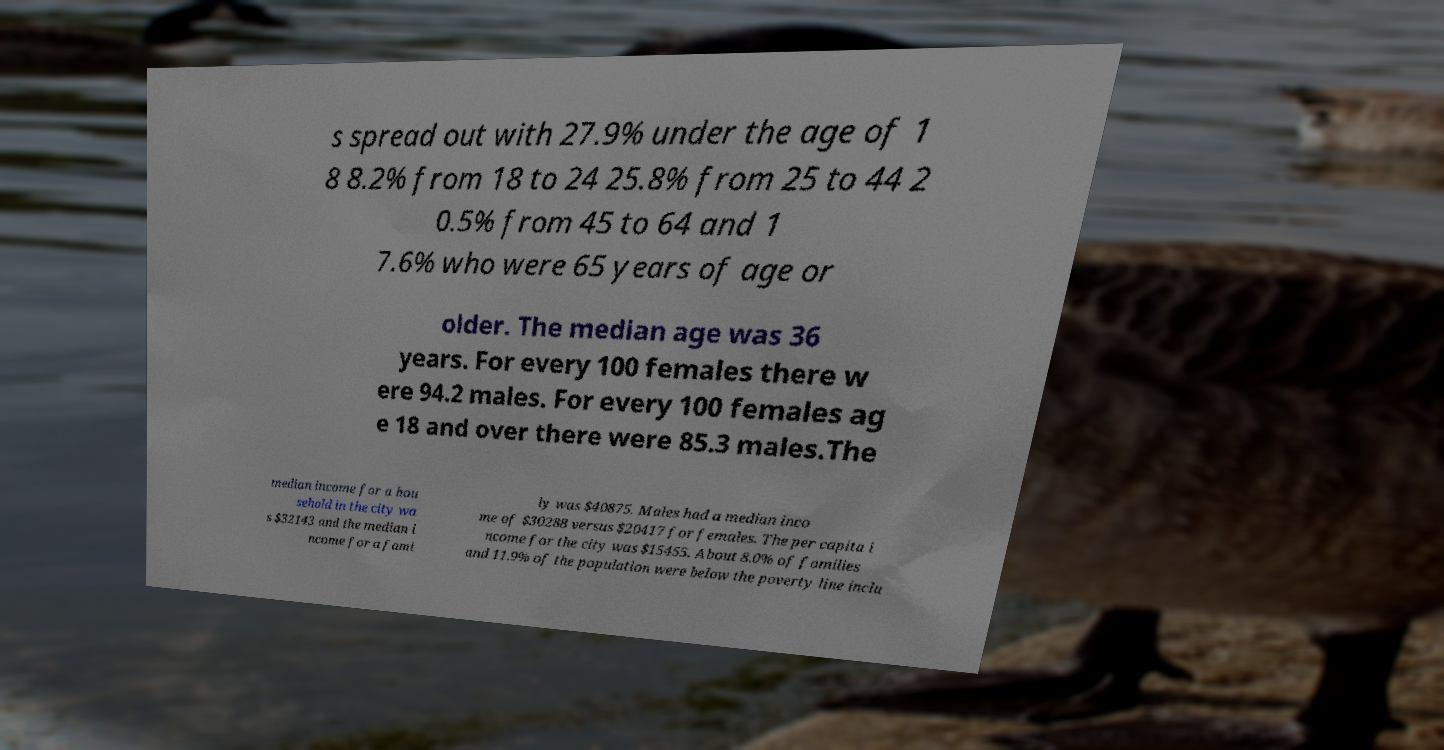Could you assist in decoding the text presented in this image and type it out clearly? s spread out with 27.9% under the age of 1 8 8.2% from 18 to 24 25.8% from 25 to 44 2 0.5% from 45 to 64 and 1 7.6% who were 65 years of age or older. The median age was 36 years. For every 100 females there w ere 94.2 males. For every 100 females ag e 18 and over there were 85.3 males.The median income for a hou sehold in the city wa s $32143 and the median i ncome for a fami ly was $40875. Males had a median inco me of $30288 versus $20417 for females. The per capita i ncome for the city was $15455. About 8.0% of families and 11.9% of the population were below the poverty line inclu 